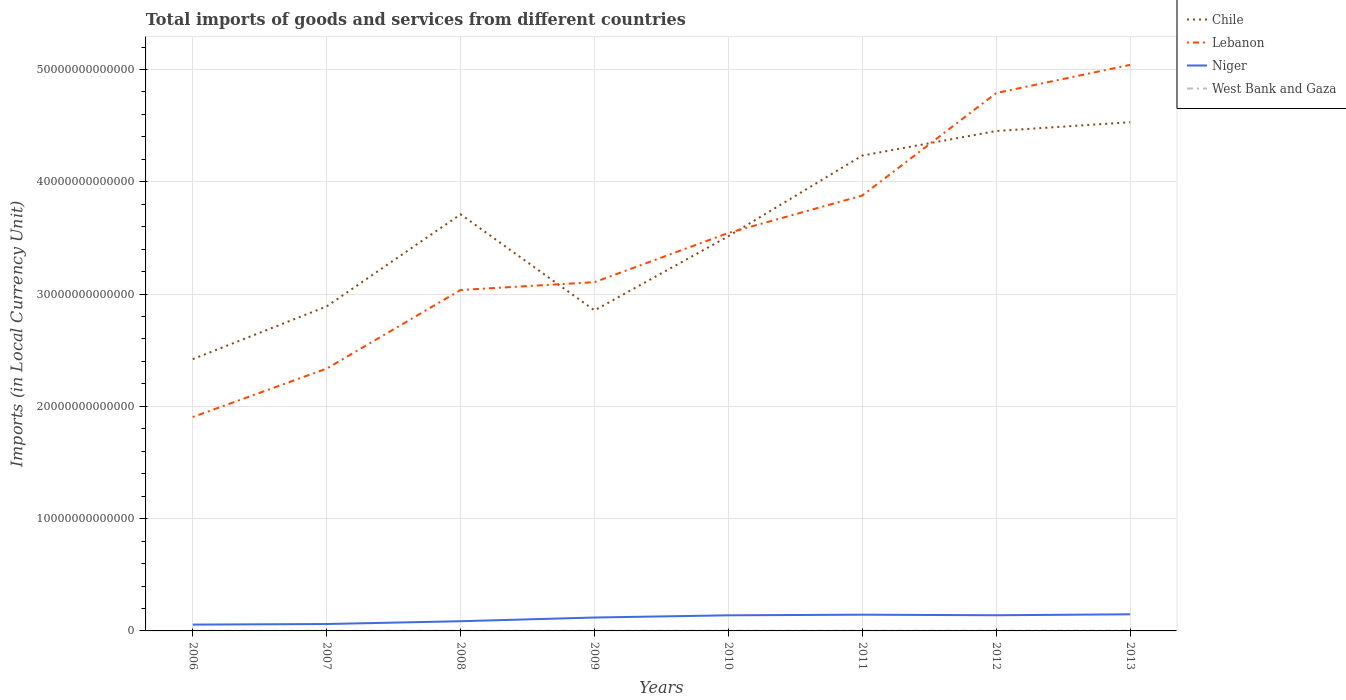How many different coloured lines are there?
Your answer should be very brief. 4. Across all years, what is the maximum Amount of goods and services imports in Lebanon?
Keep it short and to the point. 1.90e+13. What is the total Amount of goods and services imports in Niger in the graph?
Your response must be concise. -2.48e+11. What is the difference between the highest and the second highest Amount of goods and services imports in Niger?
Give a very brief answer. 9.18e+11. Is the Amount of goods and services imports in Chile strictly greater than the Amount of goods and services imports in Niger over the years?
Ensure brevity in your answer.  No. How many lines are there?
Your answer should be compact. 4. What is the difference between two consecutive major ticks on the Y-axis?
Your response must be concise. 1.00e+13. Does the graph contain grids?
Provide a short and direct response. Yes. Where does the legend appear in the graph?
Offer a very short reply. Top right. How many legend labels are there?
Your answer should be very brief. 4. What is the title of the graph?
Provide a succinct answer. Total imports of goods and services from different countries. What is the label or title of the X-axis?
Give a very brief answer. Years. What is the label or title of the Y-axis?
Your answer should be very brief. Imports (in Local Currency Unit). What is the Imports (in Local Currency Unit) in Chile in 2006?
Your answer should be compact. 2.42e+13. What is the Imports (in Local Currency Unit) in Lebanon in 2006?
Give a very brief answer. 1.90e+13. What is the Imports (in Local Currency Unit) in Niger in 2006?
Provide a short and direct response. 5.63e+11. What is the Imports (in Local Currency Unit) in West Bank and Gaza in 2006?
Give a very brief answer. 1.64e+1. What is the Imports (in Local Currency Unit) of Chile in 2007?
Your answer should be compact. 2.89e+13. What is the Imports (in Local Currency Unit) of Lebanon in 2007?
Keep it short and to the point. 2.34e+13. What is the Imports (in Local Currency Unit) in Niger in 2007?
Give a very brief answer. 6.15e+11. What is the Imports (in Local Currency Unit) in West Bank and Gaza in 2007?
Offer a very short reply. 1.76e+1. What is the Imports (in Local Currency Unit) of Chile in 2008?
Provide a short and direct response. 3.71e+13. What is the Imports (in Local Currency Unit) of Lebanon in 2008?
Provide a short and direct response. 3.04e+13. What is the Imports (in Local Currency Unit) of Niger in 2008?
Ensure brevity in your answer.  8.64e+11. What is the Imports (in Local Currency Unit) of West Bank and Gaza in 2008?
Ensure brevity in your answer.  1.64e+1. What is the Imports (in Local Currency Unit) in Chile in 2009?
Your answer should be compact. 2.85e+13. What is the Imports (in Local Currency Unit) in Lebanon in 2009?
Make the answer very short. 3.11e+13. What is the Imports (in Local Currency Unit) of Niger in 2009?
Offer a terse response. 1.19e+12. What is the Imports (in Local Currency Unit) of West Bank and Gaza in 2009?
Provide a short and direct response. 1.95e+1. What is the Imports (in Local Currency Unit) of Chile in 2010?
Your answer should be compact. 3.52e+13. What is the Imports (in Local Currency Unit) of Lebanon in 2010?
Keep it short and to the point. 3.54e+13. What is the Imports (in Local Currency Unit) of Niger in 2010?
Your response must be concise. 1.39e+12. What is the Imports (in Local Currency Unit) of West Bank and Gaza in 2010?
Your answer should be very brief. 1.96e+1. What is the Imports (in Local Currency Unit) in Chile in 2011?
Offer a very short reply. 4.23e+13. What is the Imports (in Local Currency Unit) in Lebanon in 2011?
Make the answer very short. 3.88e+13. What is the Imports (in Local Currency Unit) in Niger in 2011?
Keep it short and to the point. 1.45e+12. What is the Imports (in Local Currency Unit) of West Bank and Gaza in 2011?
Your response must be concise. 2.05e+1. What is the Imports (in Local Currency Unit) in Chile in 2012?
Offer a terse response. 4.45e+13. What is the Imports (in Local Currency Unit) in Lebanon in 2012?
Give a very brief answer. 4.79e+13. What is the Imports (in Local Currency Unit) in Niger in 2012?
Your response must be concise. 1.40e+12. What is the Imports (in Local Currency Unit) of West Bank and Gaza in 2012?
Ensure brevity in your answer.  2.43e+1. What is the Imports (in Local Currency Unit) in Chile in 2013?
Provide a succinct answer. 4.53e+13. What is the Imports (in Local Currency Unit) of Lebanon in 2013?
Provide a succinct answer. 5.04e+13. What is the Imports (in Local Currency Unit) of Niger in 2013?
Offer a very short reply. 1.48e+12. What is the Imports (in Local Currency Unit) in West Bank and Gaza in 2013?
Your response must be concise. 2.46e+1. Across all years, what is the maximum Imports (in Local Currency Unit) of Chile?
Give a very brief answer. 4.53e+13. Across all years, what is the maximum Imports (in Local Currency Unit) in Lebanon?
Make the answer very short. 5.04e+13. Across all years, what is the maximum Imports (in Local Currency Unit) of Niger?
Give a very brief answer. 1.48e+12. Across all years, what is the maximum Imports (in Local Currency Unit) in West Bank and Gaza?
Offer a terse response. 2.46e+1. Across all years, what is the minimum Imports (in Local Currency Unit) of Chile?
Offer a very short reply. 2.42e+13. Across all years, what is the minimum Imports (in Local Currency Unit) in Lebanon?
Ensure brevity in your answer.  1.90e+13. Across all years, what is the minimum Imports (in Local Currency Unit) of Niger?
Your answer should be very brief. 5.63e+11. Across all years, what is the minimum Imports (in Local Currency Unit) of West Bank and Gaza?
Make the answer very short. 1.64e+1. What is the total Imports (in Local Currency Unit) of Chile in the graph?
Your answer should be compact. 2.86e+14. What is the total Imports (in Local Currency Unit) in Lebanon in the graph?
Give a very brief answer. 2.76e+14. What is the total Imports (in Local Currency Unit) of Niger in the graph?
Make the answer very short. 8.95e+12. What is the total Imports (in Local Currency Unit) of West Bank and Gaza in the graph?
Offer a very short reply. 1.59e+11. What is the difference between the Imports (in Local Currency Unit) in Chile in 2006 and that in 2007?
Your response must be concise. -4.70e+12. What is the difference between the Imports (in Local Currency Unit) in Lebanon in 2006 and that in 2007?
Keep it short and to the point. -4.32e+12. What is the difference between the Imports (in Local Currency Unit) of Niger in 2006 and that in 2007?
Provide a short and direct response. -5.28e+1. What is the difference between the Imports (in Local Currency Unit) in West Bank and Gaza in 2006 and that in 2007?
Make the answer very short. -1.18e+09. What is the difference between the Imports (in Local Currency Unit) in Chile in 2006 and that in 2008?
Make the answer very short. -1.29e+13. What is the difference between the Imports (in Local Currency Unit) of Lebanon in 2006 and that in 2008?
Keep it short and to the point. -1.13e+13. What is the difference between the Imports (in Local Currency Unit) of Niger in 2006 and that in 2008?
Ensure brevity in your answer.  -3.01e+11. What is the difference between the Imports (in Local Currency Unit) in West Bank and Gaza in 2006 and that in 2008?
Offer a terse response. -1.64e+07. What is the difference between the Imports (in Local Currency Unit) of Chile in 2006 and that in 2009?
Keep it short and to the point. -4.34e+12. What is the difference between the Imports (in Local Currency Unit) of Lebanon in 2006 and that in 2009?
Your response must be concise. -1.20e+13. What is the difference between the Imports (in Local Currency Unit) in Niger in 2006 and that in 2009?
Your answer should be very brief. -6.31e+11. What is the difference between the Imports (in Local Currency Unit) in West Bank and Gaza in 2006 and that in 2009?
Your answer should be compact. -3.05e+09. What is the difference between the Imports (in Local Currency Unit) in Chile in 2006 and that in 2010?
Keep it short and to the point. -1.09e+13. What is the difference between the Imports (in Local Currency Unit) of Lebanon in 2006 and that in 2010?
Keep it short and to the point. -1.64e+13. What is the difference between the Imports (in Local Currency Unit) of Niger in 2006 and that in 2010?
Provide a short and direct response. -8.28e+11. What is the difference between the Imports (in Local Currency Unit) of West Bank and Gaza in 2006 and that in 2010?
Keep it short and to the point. -3.21e+09. What is the difference between the Imports (in Local Currency Unit) of Chile in 2006 and that in 2011?
Provide a succinct answer. -1.81e+13. What is the difference between the Imports (in Local Currency Unit) of Lebanon in 2006 and that in 2011?
Your answer should be very brief. -1.97e+13. What is the difference between the Imports (in Local Currency Unit) of Niger in 2006 and that in 2011?
Offer a very short reply. -8.83e+11. What is the difference between the Imports (in Local Currency Unit) in West Bank and Gaza in 2006 and that in 2011?
Provide a short and direct response. -4.06e+09. What is the difference between the Imports (in Local Currency Unit) of Chile in 2006 and that in 2012?
Your response must be concise. -2.03e+13. What is the difference between the Imports (in Local Currency Unit) of Lebanon in 2006 and that in 2012?
Your answer should be very brief. -2.89e+13. What is the difference between the Imports (in Local Currency Unit) of Niger in 2006 and that in 2012?
Give a very brief answer. -8.32e+11. What is the difference between the Imports (in Local Currency Unit) of West Bank and Gaza in 2006 and that in 2012?
Ensure brevity in your answer.  -7.83e+09. What is the difference between the Imports (in Local Currency Unit) of Chile in 2006 and that in 2013?
Keep it short and to the point. -2.11e+13. What is the difference between the Imports (in Local Currency Unit) in Lebanon in 2006 and that in 2013?
Ensure brevity in your answer.  -3.14e+13. What is the difference between the Imports (in Local Currency Unit) in Niger in 2006 and that in 2013?
Make the answer very short. -9.18e+11. What is the difference between the Imports (in Local Currency Unit) in West Bank and Gaza in 2006 and that in 2013?
Your response must be concise. -8.13e+09. What is the difference between the Imports (in Local Currency Unit) in Chile in 2007 and that in 2008?
Give a very brief answer. -8.20e+12. What is the difference between the Imports (in Local Currency Unit) in Lebanon in 2007 and that in 2008?
Give a very brief answer. -7.00e+12. What is the difference between the Imports (in Local Currency Unit) of Niger in 2007 and that in 2008?
Your answer should be compact. -2.48e+11. What is the difference between the Imports (in Local Currency Unit) in West Bank and Gaza in 2007 and that in 2008?
Your response must be concise. 1.16e+09. What is the difference between the Imports (in Local Currency Unit) in Chile in 2007 and that in 2009?
Offer a terse response. 3.57e+11. What is the difference between the Imports (in Local Currency Unit) in Lebanon in 2007 and that in 2009?
Your answer should be very brief. -7.70e+12. What is the difference between the Imports (in Local Currency Unit) of Niger in 2007 and that in 2009?
Your answer should be compact. -5.79e+11. What is the difference between the Imports (in Local Currency Unit) in West Bank and Gaza in 2007 and that in 2009?
Make the answer very short. -1.87e+09. What is the difference between the Imports (in Local Currency Unit) of Chile in 2007 and that in 2010?
Give a very brief answer. -6.25e+12. What is the difference between the Imports (in Local Currency Unit) of Lebanon in 2007 and that in 2010?
Your answer should be very brief. -1.21e+13. What is the difference between the Imports (in Local Currency Unit) of Niger in 2007 and that in 2010?
Make the answer very short. -7.75e+11. What is the difference between the Imports (in Local Currency Unit) of West Bank and Gaza in 2007 and that in 2010?
Keep it short and to the point. -2.03e+09. What is the difference between the Imports (in Local Currency Unit) in Chile in 2007 and that in 2011?
Offer a terse response. -1.34e+13. What is the difference between the Imports (in Local Currency Unit) in Lebanon in 2007 and that in 2011?
Provide a short and direct response. -1.54e+13. What is the difference between the Imports (in Local Currency Unit) in Niger in 2007 and that in 2011?
Give a very brief answer. -8.30e+11. What is the difference between the Imports (in Local Currency Unit) of West Bank and Gaza in 2007 and that in 2011?
Keep it short and to the point. -2.88e+09. What is the difference between the Imports (in Local Currency Unit) in Chile in 2007 and that in 2012?
Provide a short and direct response. -1.56e+13. What is the difference between the Imports (in Local Currency Unit) of Lebanon in 2007 and that in 2012?
Provide a short and direct response. -2.45e+13. What is the difference between the Imports (in Local Currency Unit) of Niger in 2007 and that in 2012?
Give a very brief answer. -7.80e+11. What is the difference between the Imports (in Local Currency Unit) of West Bank and Gaza in 2007 and that in 2012?
Offer a very short reply. -6.65e+09. What is the difference between the Imports (in Local Currency Unit) in Chile in 2007 and that in 2013?
Keep it short and to the point. -1.64e+13. What is the difference between the Imports (in Local Currency Unit) in Lebanon in 2007 and that in 2013?
Provide a succinct answer. -2.70e+13. What is the difference between the Imports (in Local Currency Unit) of Niger in 2007 and that in 2013?
Keep it short and to the point. -8.65e+11. What is the difference between the Imports (in Local Currency Unit) of West Bank and Gaza in 2007 and that in 2013?
Offer a terse response. -6.95e+09. What is the difference between the Imports (in Local Currency Unit) in Chile in 2008 and that in 2009?
Make the answer very short. 8.56e+12. What is the difference between the Imports (in Local Currency Unit) of Lebanon in 2008 and that in 2009?
Your response must be concise. -6.97e+11. What is the difference between the Imports (in Local Currency Unit) in Niger in 2008 and that in 2009?
Your response must be concise. -3.31e+11. What is the difference between the Imports (in Local Currency Unit) of West Bank and Gaza in 2008 and that in 2009?
Provide a short and direct response. -3.03e+09. What is the difference between the Imports (in Local Currency Unit) of Chile in 2008 and that in 2010?
Give a very brief answer. 1.95e+12. What is the difference between the Imports (in Local Currency Unit) in Lebanon in 2008 and that in 2010?
Offer a terse response. -5.08e+12. What is the difference between the Imports (in Local Currency Unit) of Niger in 2008 and that in 2010?
Your answer should be compact. -5.27e+11. What is the difference between the Imports (in Local Currency Unit) in West Bank and Gaza in 2008 and that in 2010?
Your response must be concise. -3.19e+09. What is the difference between the Imports (in Local Currency Unit) in Chile in 2008 and that in 2011?
Offer a very short reply. -5.23e+12. What is the difference between the Imports (in Local Currency Unit) of Lebanon in 2008 and that in 2011?
Your response must be concise. -8.41e+12. What is the difference between the Imports (in Local Currency Unit) in Niger in 2008 and that in 2011?
Provide a short and direct response. -5.82e+11. What is the difference between the Imports (in Local Currency Unit) in West Bank and Gaza in 2008 and that in 2011?
Offer a very short reply. -4.04e+09. What is the difference between the Imports (in Local Currency Unit) of Chile in 2008 and that in 2012?
Provide a succinct answer. -7.42e+12. What is the difference between the Imports (in Local Currency Unit) in Lebanon in 2008 and that in 2012?
Ensure brevity in your answer.  -1.75e+13. What is the difference between the Imports (in Local Currency Unit) of Niger in 2008 and that in 2012?
Provide a succinct answer. -5.32e+11. What is the difference between the Imports (in Local Currency Unit) in West Bank and Gaza in 2008 and that in 2012?
Your answer should be very brief. -7.81e+09. What is the difference between the Imports (in Local Currency Unit) of Chile in 2008 and that in 2013?
Provide a succinct answer. -8.20e+12. What is the difference between the Imports (in Local Currency Unit) in Lebanon in 2008 and that in 2013?
Give a very brief answer. -2.00e+13. What is the difference between the Imports (in Local Currency Unit) in Niger in 2008 and that in 2013?
Provide a succinct answer. -6.17e+11. What is the difference between the Imports (in Local Currency Unit) of West Bank and Gaza in 2008 and that in 2013?
Your response must be concise. -8.12e+09. What is the difference between the Imports (in Local Currency Unit) in Chile in 2009 and that in 2010?
Your response must be concise. -6.61e+12. What is the difference between the Imports (in Local Currency Unit) in Lebanon in 2009 and that in 2010?
Offer a terse response. -4.38e+12. What is the difference between the Imports (in Local Currency Unit) in Niger in 2009 and that in 2010?
Offer a very short reply. -1.96e+11. What is the difference between the Imports (in Local Currency Unit) of West Bank and Gaza in 2009 and that in 2010?
Ensure brevity in your answer.  -1.60e+08. What is the difference between the Imports (in Local Currency Unit) in Chile in 2009 and that in 2011?
Provide a short and direct response. -1.38e+13. What is the difference between the Imports (in Local Currency Unit) in Lebanon in 2009 and that in 2011?
Offer a terse response. -7.72e+12. What is the difference between the Imports (in Local Currency Unit) of Niger in 2009 and that in 2011?
Make the answer very short. -2.51e+11. What is the difference between the Imports (in Local Currency Unit) of West Bank and Gaza in 2009 and that in 2011?
Your answer should be very brief. -1.01e+09. What is the difference between the Imports (in Local Currency Unit) of Chile in 2009 and that in 2012?
Make the answer very short. -1.60e+13. What is the difference between the Imports (in Local Currency Unit) in Lebanon in 2009 and that in 2012?
Offer a very short reply. -1.68e+13. What is the difference between the Imports (in Local Currency Unit) in Niger in 2009 and that in 2012?
Keep it short and to the point. -2.01e+11. What is the difference between the Imports (in Local Currency Unit) of West Bank and Gaza in 2009 and that in 2012?
Your response must be concise. -4.78e+09. What is the difference between the Imports (in Local Currency Unit) of Chile in 2009 and that in 2013?
Provide a succinct answer. -1.68e+13. What is the difference between the Imports (in Local Currency Unit) in Lebanon in 2009 and that in 2013?
Your answer should be compact. -1.94e+13. What is the difference between the Imports (in Local Currency Unit) of Niger in 2009 and that in 2013?
Your answer should be compact. -2.86e+11. What is the difference between the Imports (in Local Currency Unit) of West Bank and Gaza in 2009 and that in 2013?
Provide a short and direct response. -5.09e+09. What is the difference between the Imports (in Local Currency Unit) of Chile in 2010 and that in 2011?
Give a very brief answer. -7.18e+12. What is the difference between the Imports (in Local Currency Unit) in Lebanon in 2010 and that in 2011?
Offer a very short reply. -3.33e+12. What is the difference between the Imports (in Local Currency Unit) of Niger in 2010 and that in 2011?
Make the answer very short. -5.48e+1. What is the difference between the Imports (in Local Currency Unit) in West Bank and Gaza in 2010 and that in 2011?
Give a very brief answer. -8.53e+08. What is the difference between the Imports (in Local Currency Unit) in Chile in 2010 and that in 2012?
Ensure brevity in your answer.  -9.37e+12. What is the difference between the Imports (in Local Currency Unit) in Lebanon in 2010 and that in 2012?
Keep it short and to the point. -1.25e+13. What is the difference between the Imports (in Local Currency Unit) in Niger in 2010 and that in 2012?
Your answer should be compact. -4.62e+09. What is the difference between the Imports (in Local Currency Unit) of West Bank and Gaza in 2010 and that in 2012?
Keep it short and to the point. -4.62e+09. What is the difference between the Imports (in Local Currency Unit) of Chile in 2010 and that in 2013?
Give a very brief answer. -1.02e+13. What is the difference between the Imports (in Local Currency Unit) in Lebanon in 2010 and that in 2013?
Your answer should be very brief. -1.50e+13. What is the difference between the Imports (in Local Currency Unit) of Niger in 2010 and that in 2013?
Provide a short and direct response. -9.01e+1. What is the difference between the Imports (in Local Currency Unit) in West Bank and Gaza in 2010 and that in 2013?
Keep it short and to the point. -4.93e+09. What is the difference between the Imports (in Local Currency Unit) of Chile in 2011 and that in 2012?
Your answer should be compact. -2.19e+12. What is the difference between the Imports (in Local Currency Unit) of Lebanon in 2011 and that in 2012?
Offer a terse response. -9.13e+12. What is the difference between the Imports (in Local Currency Unit) of Niger in 2011 and that in 2012?
Ensure brevity in your answer.  5.02e+1. What is the difference between the Imports (in Local Currency Unit) of West Bank and Gaza in 2011 and that in 2012?
Your answer should be very brief. -3.77e+09. What is the difference between the Imports (in Local Currency Unit) of Chile in 2011 and that in 2013?
Give a very brief answer. -2.97e+12. What is the difference between the Imports (in Local Currency Unit) in Lebanon in 2011 and that in 2013?
Make the answer very short. -1.16e+13. What is the difference between the Imports (in Local Currency Unit) of Niger in 2011 and that in 2013?
Give a very brief answer. -3.53e+1. What is the difference between the Imports (in Local Currency Unit) in West Bank and Gaza in 2011 and that in 2013?
Offer a terse response. -4.07e+09. What is the difference between the Imports (in Local Currency Unit) of Chile in 2012 and that in 2013?
Your answer should be very brief. -7.85e+11. What is the difference between the Imports (in Local Currency Unit) of Lebanon in 2012 and that in 2013?
Give a very brief answer. -2.51e+12. What is the difference between the Imports (in Local Currency Unit) in Niger in 2012 and that in 2013?
Make the answer very short. -8.54e+1. What is the difference between the Imports (in Local Currency Unit) of West Bank and Gaza in 2012 and that in 2013?
Offer a very short reply. -3.08e+08. What is the difference between the Imports (in Local Currency Unit) of Chile in 2006 and the Imports (in Local Currency Unit) of Lebanon in 2007?
Give a very brief answer. 8.40e+11. What is the difference between the Imports (in Local Currency Unit) in Chile in 2006 and the Imports (in Local Currency Unit) in Niger in 2007?
Provide a short and direct response. 2.36e+13. What is the difference between the Imports (in Local Currency Unit) of Chile in 2006 and the Imports (in Local Currency Unit) of West Bank and Gaza in 2007?
Your response must be concise. 2.42e+13. What is the difference between the Imports (in Local Currency Unit) of Lebanon in 2006 and the Imports (in Local Currency Unit) of Niger in 2007?
Ensure brevity in your answer.  1.84e+13. What is the difference between the Imports (in Local Currency Unit) in Lebanon in 2006 and the Imports (in Local Currency Unit) in West Bank and Gaza in 2007?
Offer a very short reply. 1.90e+13. What is the difference between the Imports (in Local Currency Unit) of Niger in 2006 and the Imports (in Local Currency Unit) of West Bank and Gaza in 2007?
Make the answer very short. 5.45e+11. What is the difference between the Imports (in Local Currency Unit) of Chile in 2006 and the Imports (in Local Currency Unit) of Lebanon in 2008?
Give a very brief answer. -6.16e+12. What is the difference between the Imports (in Local Currency Unit) in Chile in 2006 and the Imports (in Local Currency Unit) in Niger in 2008?
Make the answer very short. 2.33e+13. What is the difference between the Imports (in Local Currency Unit) of Chile in 2006 and the Imports (in Local Currency Unit) of West Bank and Gaza in 2008?
Give a very brief answer. 2.42e+13. What is the difference between the Imports (in Local Currency Unit) of Lebanon in 2006 and the Imports (in Local Currency Unit) of Niger in 2008?
Make the answer very short. 1.82e+13. What is the difference between the Imports (in Local Currency Unit) of Lebanon in 2006 and the Imports (in Local Currency Unit) of West Bank and Gaza in 2008?
Ensure brevity in your answer.  1.90e+13. What is the difference between the Imports (in Local Currency Unit) of Niger in 2006 and the Imports (in Local Currency Unit) of West Bank and Gaza in 2008?
Provide a succinct answer. 5.46e+11. What is the difference between the Imports (in Local Currency Unit) in Chile in 2006 and the Imports (in Local Currency Unit) in Lebanon in 2009?
Make the answer very short. -6.86e+12. What is the difference between the Imports (in Local Currency Unit) in Chile in 2006 and the Imports (in Local Currency Unit) in Niger in 2009?
Keep it short and to the point. 2.30e+13. What is the difference between the Imports (in Local Currency Unit) of Chile in 2006 and the Imports (in Local Currency Unit) of West Bank and Gaza in 2009?
Offer a terse response. 2.42e+13. What is the difference between the Imports (in Local Currency Unit) of Lebanon in 2006 and the Imports (in Local Currency Unit) of Niger in 2009?
Offer a very short reply. 1.79e+13. What is the difference between the Imports (in Local Currency Unit) in Lebanon in 2006 and the Imports (in Local Currency Unit) in West Bank and Gaza in 2009?
Offer a very short reply. 1.90e+13. What is the difference between the Imports (in Local Currency Unit) of Niger in 2006 and the Imports (in Local Currency Unit) of West Bank and Gaza in 2009?
Give a very brief answer. 5.43e+11. What is the difference between the Imports (in Local Currency Unit) in Chile in 2006 and the Imports (in Local Currency Unit) in Lebanon in 2010?
Your answer should be very brief. -1.12e+13. What is the difference between the Imports (in Local Currency Unit) in Chile in 2006 and the Imports (in Local Currency Unit) in Niger in 2010?
Provide a short and direct response. 2.28e+13. What is the difference between the Imports (in Local Currency Unit) in Chile in 2006 and the Imports (in Local Currency Unit) in West Bank and Gaza in 2010?
Your answer should be compact. 2.42e+13. What is the difference between the Imports (in Local Currency Unit) of Lebanon in 2006 and the Imports (in Local Currency Unit) of Niger in 2010?
Your response must be concise. 1.77e+13. What is the difference between the Imports (in Local Currency Unit) in Lebanon in 2006 and the Imports (in Local Currency Unit) in West Bank and Gaza in 2010?
Provide a succinct answer. 1.90e+13. What is the difference between the Imports (in Local Currency Unit) of Niger in 2006 and the Imports (in Local Currency Unit) of West Bank and Gaza in 2010?
Your answer should be very brief. 5.43e+11. What is the difference between the Imports (in Local Currency Unit) of Chile in 2006 and the Imports (in Local Currency Unit) of Lebanon in 2011?
Offer a very short reply. -1.46e+13. What is the difference between the Imports (in Local Currency Unit) in Chile in 2006 and the Imports (in Local Currency Unit) in Niger in 2011?
Give a very brief answer. 2.28e+13. What is the difference between the Imports (in Local Currency Unit) of Chile in 2006 and the Imports (in Local Currency Unit) of West Bank and Gaza in 2011?
Offer a very short reply. 2.42e+13. What is the difference between the Imports (in Local Currency Unit) in Lebanon in 2006 and the Imports (in Local Currency Unit) in Niger in 2011?
Your answer should be compact. 1.76e+13. What is the difference between the Imports (in Local Currency Unit) of Lebanon in 2006 and the Imports (in Local Currency Unit) of West Bank and Gaza in 2011?
Make the answer very short. 1.90e+13. What is the difference between the Imports (in Local Currency Unit) in Niger in 2006 and the Imports (in Local Currency Unit) in West Bank and Gaza in 2011?
Provide a short and direct response. 5.42e+11. What is the difference between the Imports (in Local Currency Unit) in Chile in 2006 and the Imports (in Local Currency Unit) in Lebanon in 2012?
Provide a succinct answer. -2.37e+13. What is the difference between the Imports (in Local Currency Unit) in Chile in 2006 and the Imports (in Local Currency Unit) in Niger in 2012?
Ensure brevity in your answer.  2.28e+13. What is the difference between the Imports (in Local Currency Unit) of Chile in 2006 and the Imports (in Local Currency Unit) of West Bank and Gaza in 2012?
Offer a terse response. 2.42e+13. What is the difference between the Imports (in Local Currency Unit) of Lebanon in 2006 and the Imports (in Local Currency Unit) of Niger in 2012?
Make the answer very short. 1.77e+13. What is the difference between the Imports (in Local Currency Unit) of Lebanon in 2006 and the Imports (in Local Currency Unit) of West Bank and Gaza in 2012?
Give a very brief answer. 1.90e+13. What is the difference between the Imports (in Local Currency Unit) of Niger in 2006 and the Imports (in Local Currency Unit) of West Bank and Gaza in 2012?
Your answer should be very brief. 5.38e+11. What is the difference between the Imports (in Local Currency Unit) in Chile in 2006 and the Imports (in Local Currency Unit) in Lebanon in 2013?
Your answer should be compact. -2.62e+13. What is the difference between the Imports (in Local Currency Unit) of Chile in 2006 and the Imports (in Local Currency Unit) of Niger in 2013?
Your answer should be very brief. 2.27e+13. What is the difference between the Imports (in Local Currency Unit) in Chile in 2006 and the Imports (in Local Currency Unit) in West Bank and Gaza in 2013?
Give a very brief answer. 2.42e+13. What is the difference between the Imports (in Local Currency Unit) in Lebanon in 2006 and the Imports (in Local Currency Unit) in Niger in 2013?
Your answer should be very brief. 1.76e+13. What is the difference between the Imports (in Local Currency Unit) of Lebanon in 2006 and the Imports (in Local Currency Unit) of West Bank and Gaza in 2013?
Offer a terse response. 1.90e+13. What is the difference between the Imports (in Local Currency Unit) in Niger in 2006 and the Imports (in Local Currency Unit) in West Bank and Gaza in 2013?
Ensure brevity in your answer.  5.38e+11. What is the difference between the Imports (in Local Currency Unit) of Chile in 2007 and the Imports (in Local Currency Unit) of Lebanon in 2008?
Offer a very short reply. -1.46e+12. What is the difference between the Imports (in Local Currency Unit) in Chile in 2007 and the Imports (in Local Currency Unit) in Niger in 2008?
Offer a terse response. 2.80e+13. What is the difference between the Imports (in Local Currency Unit) in Chile in 2007 and the Imports (in Local Currency Unit) in West Bank and Gaza in 2008?
Your answer should be very brief. 2.89e+13. What is the difference between the Imports (in Local Currency Unit) of Lebanon in 2007 and the Imports (in Local Currency Unit) of Niger in 2008?
Provide a succinct answer. 2.25e+13. What is the difference between the Imports (in Local Currency Unit) of Lebanon in 2007 and the Imports (in Local Currency Unit) of West Bank and Gaza in 2008?
Keep it short and to the point. 2.33e+13. What is the difference between the Imports (in Local Currency Unit) in Niger in 2007 and the Imports (in Local Currency Unit) in West Bank and Gaza in 2008?
Keep it short and to the point. 5.99e+11. What is the difference between the Imports (in Local Currency Unit) of Chile in 2007 and the Imports (in Local Currency Unit) of Lebanon in 2009?
Offer a very short reply. -2.16e+12. What is the difference between the Imports (in Local Currency Unit) in Chile in 2007 and the Imports (in Local Currency Unit) in Niger in 2009?
Offer a terse response. 2.77e+13. What is the difference between the Imports (in Local Currency Unit) in Chile in 2007 and the Imports (in Local Currency Unit) in West Bank and Gaza in 2009?
Your answer should be very brief. 2.89e+13. What is the difference between the Imports (in Local Currency Unit) of Lebanon in 2007 and the Imports (in Local Currency Unit) of Niger in 2009?
Provide a short and direct response. 2.22e+13. What is the difference between the Imports (in Local Currency Unit) in Lebanon in 2007 and the Imports (in Local Currency Unit) in West Bank and Gaza in 2009?
Keep it short and to the point. 2.33e+13. What is the difference between the Imports (in Local Currency Unit) of Niger in 2007 and the Imports (in Local Currency Unit) of West Bank and Gaza in 2009?
Your answer should be compact. 5.96e+11. What is the difference between the Imports (in Local Currency Unit) of Chile in 2007 and the Imports (in Local Currency Unit) of Lebanon in 2010?
Offer a very short reply. -6.54e+12. What is the difference between the Imports (in Local Currency Unit) of Chile in 2007 and the Imports (in Local Currency Unit) of Niger in 2010?
Your response must be concise. 2.75e+13. What is the difference between the Imports (in Local Currency Unit) in Chile in 2007 and the Imports (in Local Currency Unit) in West Bank and Gaza in 2010?
Keep it short and to the point. 2.89e+13. What is the difference between the Imports (in Local Currency Unit) of Lebanon in 2007 and the Imports (in Local Currency Unit) of Niger in 2010?
Keep it short and to the point. 2.20e+13. What is the difference between the Imports (in Local Currency Unit) of Lebanon in 2007 and the Imports (in Local Currency Unit) of West Bank and Gaza in 2010?
Give a very brief answer. 2.33e+13. What is the difference between the Imports (in Local Currency Unit) in Niger in 2007 and the Imports (in Local Currency Unit) in West Bank and Gaza in 2010?
Ensure brevity in your answer.  5.96e+11. What is the difference between the Imports (in Local Currency Unit) of Chile in 2007 and the Imports (in Local Currency Unit) of Lebanon in 2011?
Ensure brevity in your answer.  -9.87e+12. What is the difference between the Imports (in Local Currency Unit) in Chile in 2007 and the Imports (in Local Currency Unit) in Niger in 2011?
Make the answer very short. 2.75e+13. What is the difference between the Imports (in Local Currency Unit) in Chile in 2007 and the Imports (in Local Currency Unit) in West Bank and Gaza in 2011?
Ensure brevity in your answer.  2.89e+13. What is the difference between the Imports (in Local Currency Unit) of Lebanon in 2007 and the Imports (in Local Currency Unit) of Niger in 2011?
Ensure brevity in your answer.  2.19e+13. What is the difference between the Imports (in Local Currency Unit) of Lebanon in 2007 and the Imports (in Local Currency Unit) of West Bank and Gaza in 2011?
Make the answer very short. 2.33e+13. What is the difference between the Imports (in Local Currency Unit) in Niger in 2007 and the Imports (in Local Currency Unit) in West Bank and Gaza in 2011?
Keep it short and to the point. 5.95e+11. What is the difference between the Imports (in Local Currency Unit) of Chile in 2007 and the Imports (in Local Currency Unit) of Lebanon in 2012?
Your answer should be very brief. -1.90e+13. What is the difference between the Imports (in Local Currency Unit) of Chile in 2007 and the Imports (in Local Currency Unit) of Niger in 2012?
Your answer should be very brief. 2.75e+13. What is the difference between the Imports (in Local Currency Unit) in Chile in 2007 and the Imports (in Local Currency Unit) in West Bank and Gaza in 2012?
Offer a very short reply. 2.89e+13. What is the difference between the Imports (in Local Currency Unit) in Lebanon in 2007 and the Imports (in Local Currency Unit) in Niger in 2012?
Your response must be concise. 2.20e+13. What is the difference between the Imports (in Local Currency Unit) of Lebanon in 2007 and the Imports (in Local Currency Unit) of West Bank and Gaza in 2012?
Provide a short and direct response. 2.33e+13. What is the difference between the Imports (in Local Currency Unit) in Niger in 2007 and the Imports (in Local Currency Unit) in West Bank and Gaza in 2012?
Your response must be concise. 5.91e+11. What is the difference between the Imports (in Local Currency Unit) in Chile in 2007 and the Imports (in Local Currency Unit) in Lebanon in 2013?
Your answer should be very brief. -2.15e+13. What is the difference between the Imports (in Local Currency Unit) in Chile in 2007 and the Imports (in Local Currency Unit) in Niger in 2013?
Offer a terse response. 2.74e+13. What is the difference between the Imports (in Local Currency Unit) in Chile in 2007 and the Imports (in Local Currency Unit) in West Bank and Gaza in 2013?
Offer a very short reply. 2.89e+13. What is the difference between the Imports (in Local Currency Unit) in Lebanon in 2007 and the Imports (in Local Currency Unit) in Niger in 2013?
Keep it short and to the point. 2.19e+13. What is the difference between the Imports (in Local Currency Unit) in Lebanon in 2007 and the Imports (in Local Currency Unit) in West Bank and Gaza in 2013?
Keep it short and to the point. 2.33e+13. What is the difference between the Imports (in Local Currency Unit) in Niger in 2007 and the Imports (in Local Currency Unit) in West Bank and Gaza in 2013?
Keep it short and to the point. 5.91e+11. What is the difference between the Imports (in Local Currency Unit) in Chile in 2008 and the Imports (in Local Currency Unit) in Lebanon in 2009?
Provide a succinct answer. 6.04e+12. What is the difference between the Imports (in Local Currency Unit) of Chile in 2008 and the Imports (in Local Currency Unit) of Niger in 2009?
Your answer should be very brief. 3.59e+13. What is the difference between the Imports (in Local Currency Unit) in Chile in 2008 and the Imports (in Local Currency Unit) in West Bank and Gaza in 2009?
Offer a very short reply. 3.71e+13. What is the difference between the Imports (in Local Currency Unit) in Lebanon in 2008 and the Imports (in Local Currency Unit) in Niger in 2009?
Your response must be concise. 2.92e+13. What is the difference between the Imports (in Local Currency Unit) of Lebanon in 2008 and the Imports (in Local Currency Unit) of West Bank and Gaza in 2009?
Keep it short and to the point. 3.03e+13. What is the difference between the Imports (in Local Currency Unit) in Niger in 2008 and the Imports (in Local Currency Unit) in West Bank and Gaza in 2009?
Keep it short and to the point. 8.44e+11. What is the difference between the Imports (in Local Currency Unit) in Chile in 2008 and the Imports (in Local Currency Unit) in Lebanon in 2010?
Give a very brief answer. 1.66e+12. What is the difference between the Imports (in Local Currency Unit) of Chile in 2008 and the Imports (in Local Currency Unit) of Niger in 2010?
Make the answer very short. 3.57e+13. What is the difference between the Imports (in Local Currency Unit) in Chile in 2008 and the Imports (in Local Currency Unit) in West Bank and Gaza in 2010?
Your response must be concise. 3.71e+13. What is the difference between the Imports (in Local Currency Unit) of Lebanon in 2008 and the Imports (in Local Currency Unit) of Niger in 2010?
Your response must be concise. 2.90e+13. What is the difference between the Imports (in Local Currency Unit) in Lebanon in 2008 and the Imports (in Local Currency Unit) in West Bank and Gaza in 2010?
Your response must be concise. 3.03e+13. What is the difference between the Imports (in Local Currency Unit) in Niger in 2008 and the Imports (in Local Currency Unit) in West Bank and Gaza in 2010?
Your answer should be very brief. 8.44e+11. What is the difference between the Imports (in Local Currency Unit) of Chile in 2008 and the Imports (in Local Currency Unit) of Lebanon in 2011?
Your answer should be very brief. -1.67e+12. What is the difference between the Imports (in Local Currency Unit) of Chile in 2008 and the Imports (in Local Currency Unit) of Niger in 2011?
Ensure brevity in your answer.  3.57e+13. What is the difference between the Imports (in Local Currency Unit) in Chile in 2008 and the Imports (in Local Currency Unit) in West Bank and Gaza in 2011?
Your answer should be compact. 3.71e+13. What is the difference between the Imports (in Local Currency Unit) in Lebanon in 2008 and the Imports (in Local Currency Unit) in Niger in 2011?
Your answer should be very brief. 2.89e+13. What is the difference between the Imports (in Local Currency Unit) in Lebanon in 2008 and the Imports (in Local Currency Unit) in West Bank and Gaza in 2011?
Keep it short and to the point. 3.03e+13. What is the difference between the Imports (in Local Currency Unit) of Niger in 2008 and the Imports (in Local Currency Unit) of West Bank and Gaza in 2011?
Ensure brevity in your answer.  8.43e+11. What is the difference between the Imports (in Local Currency Unit) of Chile in 2008 and the Imports (in Local Currency Unit) of Lebanon in 2012?
Keep it short and to the point. -1.08e+13. What is the difference between the Imports (in Local Currency Unit) of Chile in 2008 and the Imports (in Local Currency Unit) of Niger in 2012?
Keep it short and to the point. 3.57e+13. What is the difference between the Imports (in Local Currency Unit) in Chile in 2008 and the Imports (in Local Currency Unit) in West Bank and Gaza in 2012?
Provide a short and direct response. 3.71e+13. What is the difference between the Imports (in Local Currency Unit) in Lebanon in 2008 and the Imports (in Local Currency Unit) in Niger in 2012?
Offer a very short reply. 2.90e+13. What is the difference between the Imports (in Local Currency Unit) of Lebanon in 2008 and the Imports (in Local Currency Unit) of West Bank and Gaza in 2012?
Your answer should be very brief. 3.03e+13. What is the difference between the Imports (in Local Currency Unit) of Niger in 2008 and the Imports (in Local Currency Unit) of West Bank and Gaza in 2012?
Provide a succinct answer. 8.39e+11. What is the difference between the Imports (in Local Currency Unit) of Chile in 2008 and the Imports (in Local Currency Unit) of Lebanon in 2013?
Give a very brief answer. -1.33e+13. What is the difference between the Imports (in Local Currency Unit) in Chile in 2008 and the Imports (in Local Currency Unit) in Niger in 2013?
Your response must be concise. 3.56e+13. What is the difference between the Imports (in Local Currency Unit) in Chile in 2008 and the Imports (in Local Currency Unit) in West Bank and Gaza in 2013?
Your response must be concise. 3.71e+13. What is the difference between the Imports (in Local Currency Unit) in Lebanon in 2008 and the Imports (in Local Currency Unit) in Niger in 2013?
Provide a succinct answer. 2.89e+13. What is the difference between the Imports (in Local Currency Unit) in Lebanon in 2008 and the Imports (in Local Currency Unit) in West Bank and Gaza in 2013?
Give a very brief answer. 3.03e+13. What is the difference between the Imports (in Local Currency Unit) in Niger in 2008 and the Imports (in Local Currency Unit) in West Bank and Gaza in 2013?
Make the answer very short. 8.39e+11. What is the difference between the Imports (in Local Currency Unit) in Chile in 2009 and the Imports (in Local Currency Unit) in Lebanon in 2010?
Offer a very short reply. -6.90e+12. What is the difference between the Imports (in Local Currency Unit) of Chile in 2009 and the Imports (in Local Currency Unit) of Niger in 2010?
Offer a terse response. 2.72e+13. What is the difference between the Imports (in Local Currency Unit) of Chile in 2009 and the Imports (in Local Currency Unit) of West Bank and Gaza in 2010?
Provide a short and direct response. 2.85e+13. What is the difference between the Imports (in Local Currency Unit) in Lebanon in 2009 and the Imports (in Local Currency Unit) in Niger in 2010?
Provide a short and direct response. 2.97e+13. What is the difference between the Imports (in Local Currency Unit) in Lebanon in 2009 and the Imports (in Local Currency Unit) in West Bank and Gaza in 2010?
Ensure brevity in your answer.  3.10e+13. What is the difference between the Imports (in Local Currency Unit) of Niger in 2009 and the Imports (in Local Currency Unit) of West Bank and Gaza in 2010?
Ensure brevity in your answer.  1.17e+12. What is the difference between the Imports (in Local Currency Unit) in Chile in 2009 and the Imports (in Local Currency Unit) in Lebanon in 2011?
Offer a very short reply. -1.02e+13. What is the difference between the Imports (in Local Currency Unit) of Chile in 2009 and the Imports (in Local Currency Unit) of Niger in 2011?
Offer a terse response. 2.71e+13. What is the difference between the Imports (in Local Currency Unit) of Chile in 2009 and the Imports (in Local Currency Unit) of West Bank and Gaza in 2011?
Make the answer very short. 2.85e+13. What is the difference between the Imports (in Local Currency Unit) of Lebanon in 2009 and the Imports (in Local Currency Unit) of Niger in 2011?
Your answer should be very brief. 2.96e+13. What is the difference between the Imports (in Local Currency Unit) in Lebanon in 2009 and the Imports (in Local Currency Unit) in West Bank and Gaza in 2011?
Your response must be concise. 3.10e+13. What is the difference between the Imports (in Local Currency Unit) of Niger in 2009 and the Imports (in Local Currency Unit) of West Bank and Gaza in 2011?
Make the answer very short. 1.17e+12. What is the difference between the Imports (in Local Currency Unit) of Chile in 2009 and the Imports (in Local Currency Unit) of Lebanon in 2012?
Offer a very short reply. -1.94e+13. What is the difference between the Imports (in Local Currency Unit) of Chile in 2009 and the Imports (in Local Currency Unit) of Niger in 2012?
Offer a terse response. 2.71e+13. What is the difference between the Imports (in Local Currency Unit) in Chile in 2009 and the Imports (in Local Currency Unit) in West Bank and Gaza in 2012?
Keep it short and to the point. 2.85e+13. What is the difference between the Imports (in Local Currency Unit) of Lebanon in 2009 and the Imports (in Local Currency Unit) of Niger in 2012?
Provide a short and direct response. 2.97e+13. What is the difference between the Imports (in Local Currency Unit) of Lebanon in 2009 and the Imports (in Local Currency Unit) of West Bank and Gaza in 2012?
Keep it short and to the point. 3.10e+13. What is the difference between the Imports (in Local Currency Unit) of Niger in 2009 and the Imports (in Local Currency Unit) of West Bank and Gaza in 2012?
Provide a short and direct response. 1.17e+12. What is the difference between the Imports (in Local Currency Unit) in Chile in 2009 and the Imports (in Local Currency Unit) in Lebanon in 2013?
Offer a very short reply. -2.19e+13. What is the difference between the Imports (in Local Currency Unit) in Chile in 2009 and the Imports (in Local Currency Unit) in Niger in 2013?
Your response must be concise. 2.71e+13. What is the difference between the Imports (in Local Currency Unit) in Chile in 2009 and the Imports (in Local Currency Unit) in West Bank and Gaza in 2013?
Ensure brevity in your answer.  2.85e+13. What is the difference between the Imports (in Local Currency Unit) in Lebanon in 2009 and the Imports (in Local Currency Unit) in Niger in 2013?
Make the answer very short. 2.96e+13. What is the difference between the Imports (in Local Currency Unit) in Lebanon in 2009 and the Imports (in Local Currency Unit) in West Bank and Gaza in 2013?
Ensure brevity in your answer.  3.10e+13. What is the difference between the Imports (in Local Currency Unit) of Niger in 2009 and the Imports (in Local Currency Unit) of West Bank and Gaza in 2013?
Your answer should be compact. 1.17e+12. What is the difference between the Imports (in Local Currency Unit) in Chile in 2010 and the Imports (in Local Currency Unit) in Lebanon in 2011?
Your response must be concise. -3.62e+12. What is the difference between the Imports (in Local Currency Unit) in Chile in 2010 and the Imports (in Local Currency Unit) in Niger in 2011?
Keep it short and to the point. 3.37e+13. What is the difference between the Imports (in Local Currency Unit) of Chile in 2010 and the Imports (in Local Currency Unit) of West Bank and Gaza in 2011?
Provide a succinct answer. 3.51e+13. What is the difference between the Imports (in Local Currency Unit) in Lebanon in 2010 and the Imports (in Local Currency Unit) in Niger in 2011?
Provide a succinct answer. 3.40e+13. What is the difference between the Imports (in Local Currency Unit) in Lebanon in 2010 and the Imports (in Local Currency Unit) in West Bank and Gaza in 2011?
Your answer should be very brief. 3.54e+13. What is the difference between the Imports (in Local Currency Unit) of Niger in 2010 and the Imports (in Local Currency Unit) of West Bank and Gaza in 2011?
Your response must be concise. 1.37e+12. What is the difference between the Imports (in Local Currency Unit) in Chile in 2010 and the Imports (in Local Currency Unit) in Lebanon in 2012?
Your answer should be compact. -1.28e+13. What is the difference between the Imports (in Local Currency Unit) in Chile in 2010 and the Imports (in Local Currency Unit) in Niger in 2012?
Your answer should be compact. 3.38e+13. What is the difference between the Imports (in Local Currency Unit) of Chile in 2010 and the Imports (in Local Currency Unit) of West Bank and Gaza in 2012?
Your response must be concise. 3.51e+13. What is the difference between the Imports (in Local Currency Unit) in Lebanon in 2010 and the Imports (in Local Currency Unit) in Niger in 2012?
Offer a very short reply. 3.40e+13. What is the difference between the Imports (in Local Currency Unit) of Lebanon in 2010 and the Imports (in Local Currency Unit) of West Bank and Gaza in 2012?
Provide a succinct answer. 3.54e+13. What is the difference between the Imports (in Local Currency Unit) in Niger in 2010 and the Imports (in Local Currency Unit) in West Bank and Gaza in 2012?
Provide a short and direct response. 1.37e+12. What is the difference between the Imports (in Local Currency Unit) of Chile in 2010 and the Imports (in Local Currency Unit) of Lebanon in 2013?
Give a very brief answer. -1.53e+13. What is the difference between the Imports (in Local Currency Unit) in Chile in 2010 and the Imports (in Local Currency Unit) in Niger in 2013?
Provide a succinct answer. 3.37e+13. What is the difference between the Imports (in Local Currency Unit) in Chile in 2010 and the Imports (in Local Currency Unit) in West Bank and Gaza in 2013?
Your response must be concise. 3.51e+13. What is the difference between the Imports (in Local Currency Unit) of Lebanon in 2010 and the Imports (in Local Currency Unit) of Niger in 2013?
Your answer should be compact. 3.40e+13. What is the difference between the Imports (in Local Currency Unit) of Lebanon in 2010 and the Imports (in Local Currency Unit) of West Bank and Gaza in 2013?
Provide a succinct answer. 3.54e+13. What is the difference between the Imports (in Local Currency Unit) of Niger in 2010 and the Imports (in Local Currency Unit) of West Bank and Gaza in 2013?
Your answer should be compact. 1.37e+12. What is the difference between the Imports (in Local Currency Unit) of Chile in 2011 and the Imports (in Local Currency Unit) of Lebanon in 2012?
Keep it short and to the point. -5.57e+12. What is the difference between the Imports (in Local Currency Unit) of Chile in 2011 and the Imports (in Local Currency Unit) of Niger in 2012?
Give a very brief answer. 4.09e+13. What is the difference between the Imports (in Local Currency Unit) of Chile in 2011 and the Imports (in Local Currency Unit) of West Bank and Gaza in 2012?
Make the answer very short. 4.23e+13. What is the difference between the Imports (in Local Currency Unit) in Lebanon in 2011 and the Imports (in Local Currency Unit) in Niger in 2012?
Provide a succinct answer. 3.74e+13. What is the difference between the Imports (in Local Currency Unit) in Lebanon in 2011 and the Imports (in Local Currency Unit) in West Bank and Gaza in 2012?
Your answer should be compact. 3.88e+13. What is the difference between the Imports (in Local Currency Unit) in Niger in 2011 and the Imports (in Local Currency Unit) in West Bank and Gaza in 2012?
Your answer should be compact. 1.42e+12. What is the difference between the Imports (in Local Currency Unit) of Chile in 2011 and the Imports (in Local Currency Unit) of Lebanon in 2013?
Your answer should be compact. -8.08e+12. What is the difference between the Imports (in Local Currency Unit) of Chile in 2011 and the Imports (in Local Currency Unit) of Niger in 2013?
Provide a succinct answer. 4.09e+13. What is the difference between the Imports (in Local Currency Unit) of Chile in 2011 and the Imports (in Local Currency Unit) of West Bank and Gaza in 2013?
Make the answer very short. 4.23e+13. What is the difference between the Imports (in Local Currency Unit) in Lebanon in 2011 and the Imports (in Local Currency Unit) in Niger in 2013?
Give a very brief answer. 3.73e+13. What is the difference between the Imports (in Local Currency Unit) in Lebanon in 2011 and the Imports (in Local Currency Unit) in West Bank and Gaza in 2013?
Make the answer very short. 3.88e+13. What is the difference between the Imports (in Local Currency Unit) in Niger in 2011 and the Imports (in Local Currency Unit) in West Bank and Gaza in 2013?
Ensure brevity in your answer.  1.42e+12. What is the difference between the Imports (in Local Currency Unit) in Chile in 2012 and the Imports (in Local Currency Unit) in Lebanon in 2013?
Offer a very short reply. -5.89e+12. What is the difference between the Imports (in Local Currency Unit) in Chile in 2012 and the Imports (in Local Currency Unit) in Niger in 2013?
Ensure brevity in your answer.  4.30e+13. What is the difference between the Imports (in Local Currency Unit) of Chile in 2012 and the Imports (in Local Currency Unit) of West Bank and Gaza in 2013?
Keep it short and to the point. 4.45e+13. What is the difference between the Imports (in Local Currency Unit) in Lebanon in 2012 and the Imports (in Local Currency Unit) in Niger in 2013?
Keep it short and to the point. 4.64e+13. What is the difference between the Imports (in Local Currency Unit) of Lebanon in 2012 and the Imports (in Local Currency Unit) of West Bank and Gaza in 2013?
Your answer should be compact. 4.79e+13. What is the difference between the Imports (in Local Currency Unit) in Niger in 2012 and the Imports (in Local Currency Unit) in West Bank and Gaza in 2013?
Your response must be concise. 1.37e+12. What is the average Imports (in Local Currency Unit) in Chile per year?
Your answer should be very brief. 3.58e+13. What is the average Imports (in Local Currency Unit) of Lebanon per year?
Make the answer very short. 3.45e+13. What is the average Imports (in Local Currency Unit) of Niger per year?
Your answer should be compact. 1.12e+12. What is the average Imports (in Local Currency Unit) in West Bank and Gaza per year?
Keep it short and to the point. 1.99e+1. In the year 2006, what is the difference between the Imports (in Local Currency Unit) of Chile and Imports (in Local Currency Unit) of Lebanon?
Ensure brevity in your answer.  5.16e+12. In the year 2006, what is the difference between the Imports (in Local Currency Unit) of Chile and Imports (in Local Currency Unit) of Niger?
Your response must be concise. 2.36e+13. In the year 2006, what is the difference between the Imports (in Local Currency Unit) of Chile and Imports (in Local Currency Unit) of West Bank and Gaza?
Ensure brevity in your answer.  2.42e+13. In the year 2006, what is the difference between the Imports (in Local Currency Unit) of Lebanon and Imports (in Local Currency Unit) of Niger?
Your answer should be compact. 1.85e+13. In the year 2006, what is the difference between the Imports (in Local Currency Unit) in Lebanon and Imports (in Local Currency Unit) in West Bank and Gaza?
Make the answer very short. 1.90e+13. In the year 2006, what is the difference between the Imports (in Local Currency Unit) in Niger and Imports (in Local Currency Unit) in West Bank and Gaza?
Your answer should be very brief. 5.46e+11. In the year 2007, what is the difference between the Imports (in Local Currency Unit) of Chile and Imports (in Local Currency Unit) of Lebanon?
Give a very brief answer. 5.54e+12. In the year 2007, what is the difference between the Imports (in Local Currency Unit) in Chile and Imports (in Local Currency Unit) in Niger?
Provide a short and direct response. 2.83e+13. In the year 2007, what is the difference between the Imports (in Local Currency Unit) in Chile and Imports (in Local Currency Unit) in West Bank and Gaza?
Your answer should be compact. 2.89e+13. In the year 2007, what is the difference between the Imports (in Local Currency Unit) in Lebanon and Imports (in Local Currency Unit) in Niger?
Provide a short and direct response. 2.27e+13. In the year 2007, what is the difference between the Imports (in Local Currency Unit) in Lebanon and Imports (in Local Currency Unit) in West Bank and Gaza?
Your response must be concise. 2.33e+13. In the year 2007, what is the difference between the Imports (in Local Currency Unit) in Niger and Imports (in Local Currency Unit) in West Bank and Gaza?
Offer a terse response. 5.98e+11. In the year 2008, what is the difference between the Imports (in Local Currency Unit) of Chile and Imports (in Local Currency Unit) of Lebanon?
Your answer should be very brief. 6.74e+12. In the year 2008, what is the difference between the Imports (in Local Currency Unit) in Chile and Imports (in Local Currency Unit) in Niger?
Your answer should be compact. 3.62e+13. In the year 2008, what is the difference between the Imports (in Local Currency Unit) of Chile and Imports (in Local Currency Unit) of West Bank and Gaza?
Provide a short and direct response. 3.71e+13. In the year 2008, what is the difference between the Imports (in Local Currency Unit) of Lebanon and Imports (in Local Currency Unit) of Niger?
Ensure brevity in your answer.  2.95e+13. In the year 2008, what is the difference between the Imports (in Local Currency Unit) in Lebanon and Imports (in Local Currency Unit) in West Bank and Gaza?
Provide a succinct answer. 3.03e+13. In the year 2008, what is the difference between the Imports (in Local Currency Unit) in Niger and Imports (in Local Currency Unit) in West Bank and Gaza?
Keep it short and to the point. 8.47e+11. In the year 2009, what is the difference between the Imports (in Local Currency Unit) in Chile and Imports (in Local Currency Unit) in Lebanon?
Make the answer very short. -2.52e+12. In the year 2009, what is the difference between the Imports (in Local Currency Unit) in Chile and Imports (in Local Currency Unit) in Niger?
Provide a short and direct response. 2.74e+13. In the year 2009, what is the difference between the Imports (in Local Currency Unit) in Chile and Imports (in Local Currency Unit) in West Bank and Gaza?
Your answer should be very brief. 2.85e+13. In the year 2009, what is the difference between the Imports (in Local Currency Unit) of Lebanon and Imports (in Local Currency Unit) of Niger?
Provide a short and direct response. 2.99e+13. In the year 2009, what is the difference between the Imports (in Local Currency Unit) in Lebanon and Imports (in Local Currency Unit) in West Bank and Gaza?
Provide a succinct answer. 3.10e+13. In the year 2009, what is the difference between the Imports (in Local Currency Unit) of Niger and Imports (in Local Currency Unit) of West Bank and Gaza?
Your answer should be compact. 1.17e+12. In the year 2010, what is the difference between the Imports (in Local Currency Unit) in Chile and Imports (in Local Currency Unit) in Lebanon?
Give a very brief answer. -2.91e+11. In the year 2010, what is the difference between the Imports (in Local Currency Unit) of Chile and Imports (in Local Currency Unit) of Niger?
Keep it short and to the point. 3.38e+13. In the year 2010, what is the difference between the Imports (in Local Currency Unit) in Chile and Imports (in Local Currency Unit) in West Bank and Gaza?
Give a very brief answer. 3.51e+13. In the year 2010, what is the difference between the Imports (in Local Currency Unit) of Lebanon and Imports (in Local Currency Unit) of Niger?
Keep it short and to the point. 3.41e+13. In the year 2010, what is the difference between the Imports (in Local Currency Unit) in Lebanon and Imports (in Local Currency Unit) in West Bank and Gaza?
Provide a short and direct response. 3.54e+13. In the year 2010, what is the difference between the Imports (in Local Currency Unit) in Niger and Imports (in Local Currency Unit) in West Bank and Gaza?
Offer a very short reply. 1.37e+12. In the year 2011, what is the difference between the Imports (in Local Currency Unit) of Chile and Imports (in Local Currency Unit) of Lebanon?
Offer a very short reply. 3.56e+12. In the year 2011, what is the difference between the Imports (in Local Currency Unit) of Chile and Imports (in Local Currency Unit) of Niger?
Give a very brief answer. 4.09e+13. In the year 2011, what is the difference between the Imports (in Local Currency Unit) in Chile and Imports (in Local Currency Unit) in West Bank and Gaza?
Provide a short and direct response. 4.23e+13. In the year 2011, what is the difference between the Imports (in Local Currency Unit) in Lebanon and Imports (in Local Currency Unit) in Niger?
Make the answer very short. 3.73e+13. In the year 2011, what is the difference between the Imports (in Local Currency Unit) of Lebanon and Imports (in Local Currency Unit) of West Bank and Gaza?
Your answer should be compact. 3.88e+13. In the year 2011, what is the difference between the Imports (in Local Currency Unit) of Niger and Imports (in Local Currency Unit) of West Bank and Gaza?
Provide a succinct answer. 1.42e+12. In the year 2012, what is the difference between the Imports (in Local Currency Unit) in Chile and Imports (in Local Currency Unit) in Lebanon?
Offer a very short reply. -3.38e+12. In the year 2012, what is the difference between the Imports (in Local Currency Unit) of Chile and Imports (in Local Currency Unit) of Niger?
Your response must be concise. 4.31e+13. In the year 2012, what is the difference between the Imports (in Local Currency Unit) of Chile and Imports (in Local Currency Unit) of West Bank and Gaza?
Ensure brevity in your answer.  4.45e+13. In the year 2012, what is the difference between the Imports (in Local Currency Unit) in Lebanon and Imports (in Local Currency Unit) in Niger?
Offer a very short reply. 4.65e+13. In the year 2012, what is the difference between the Imports (in Local Currency Unit) of Lebanon and Imports (in Local Currency Unit) of West Bank and Gaza?
Provide a short and direct response. 4.79e+13. In the year 2012, what is the difference between the Imports (in Local Currency Unit) in Niger and Imports (in Local Currency Unit) in West Bank and Gaza?
Offer a terse response. 1.37e+12. In the year 2013, what is the difference between the Imports (in Local Currency Unit) of Chile and Imports (in Local Currency Unit) of Lebanon?
Your answer should be compact. -5.11e+12. In the year 2013, what is the difference between the Imports (in Local Currency Unit) in Chile and Imports (in Local Currency Unit) in Niger?
Your answer should be compact. 4.38e+13. In the year 2013, what is the difference between the Imports (in Local Currency Unit) of Chile and Imports (in Local Currency Unit) of West Bank and Gaza?
Make the answer very short. 4.53e+13. In the year 2013, what is the difference between the Imports (in Local Currency Unit) in Lebanon and Imports (in Local Currency Unit) in Niger?
Offer a very short reply. 4.89e+13. In the year 2013, what is the difference between the Imports (in Local Currency Unit) in Lebanon and Imports (in Local Currency Unit) in West Bank and Gaza?
Your answer should be compact. 5.04e+13. In the year 2013, what is the difference between the Imports (in Local Currency Unit) in Niger and Imports (in Local Currency Unit) in West Bank and Gaza?
Your answer should be compact. 1.46e+12. What is the ratio of the Imports (in Local Currency Unit) in Chile in 2006 to that in 2007?
Provide a short and direct response. 0.84. What is the ratio of the Imports (in Local Currency Unit) of Lebanon in 2006 to that in 2007?
Your answer should be compact. 0.82. What is the ratio of the Imports (in Local Currency Unit) of Niger in 2006 to that in 2007?
Give a very brief answer. 0.91. What is the ratio of the Imports (in Local Currency Unit) of West Bank and Gaza in 2006 to that in 2007?
Offer a very short reply. 0.93. What is the ratio of the Imports (in Local Currency Unit) in Chile in 2006 to that in 2008?
Your answer should be compact. 0.65. What is the ratio of the Imports (in Local Currency Unit) of Lebanon in 2006 to that in 2008?
Ensure brevity in your answer.  0.63. What is the ratio of the Imports (in Local Currency Unit) in Niger in 2006 to that in 2008?
Your answer should be very brief. 0.65. What is the ratio of the Imports (in Local Currency Unit) in West Bank and Gaza in 2006 to that in 2008?
Offer a very short reply. 1. What is the ratio of the Imports (in Local Currency Unit) in Chile in 2006 to that in 2009?
Your response must be concise. 0.85. What is the ratio of the Imports (in Local Currency Unit) of Lebanon in 2006 to that in 2009?
Your answer should be compact. 0.61. What is the ratio of the Imports (in Local Currency Unit) in Niger in 2006 to that in 2009?
Offer a terse response. 0.47. What is the ratio of the Imports (in Local Currency Unit) of West Bank and Gaza in 2006 to that in 2009?
Provide a short and direct response. 0.84. What is the ratio of the Imports (in Local Currency Unit) in Chile in 2006 to that in 2010?
Your answer should be very brief. 0.69. What is the ratio of the Imports (in Local Currency Unit) of Lebanon in 2006 to that in 2010?
Make the answer very short. 0.54. What is the ratio of the Imports (in Local Currency Unit) in Niger in 2006 to that in 2010?
Your response must be concise. 0.4. What is the ratio of the Imports (in Local Currency Unit) in West Bank and Gaza in 2006 to that in 2010?
Your answer should be compact. 0.84. What is the ratio of the Imports (in Local Currency Unit) of Chile in 2006 to that in 2011?
Your answer should be compact. 0.57. What is the ratio of the Imports (in Local Currency Unit) of Lebanon in 2006 to that in 2011?
Your answer should be very brief. 0.49. What is the ratio of the Imports (in Local Currency Unit) of Niger in 2006 to that in 2011?
Make the answer very short. 0.39. What is the ratio of the Imports (in Local Currency Unit) of West Bank and Gaza in 2006 to that in 2011?
Provide a succinct answer. 0.8. What is the ratio of the Imports (in Local Currency Unit) in Chile in 2006 to that in 2012?
Provide a short and direct response. 0.54. What is the ratio of the Imports (in Local Currency Unit) in Lebanon in 2006 to that in 2012?
Offer a terse response. 0.4. What is the ratio of the Imports (in Local Currency Unit) in Niger in 2006 to that in 2012?
Give a very brief answer. 0.4. What is the ratio of the Imports (in Local Currency Unit) of West Bank and Gaza in 2006 to that in 2012?
Provide a succinct answer. 0.68. What is the ratio of the Imports (in Local Currency Unit) of Chile in 2006 to that in 2013?
Your answer should be very brief. 0.53. What is the ratio of the Imports (in Local Currency Unit) of Lebanon in 2006 to that in 2013?
Your answer should be compact. 0.38. What is the ratio of the Imports (in Local Currency Unit) in Niger in 2006 to that in 2013?
Your answer should be compact. 0.38. What is the ratio of the Imports (in Local Currency Unit) of West Bank and Gaza in 2006 to that in 2013?
Give a very brief answer. 0.67. What is the ratio of the Imports (in Local Currency Unit) of Chile in 2007 to that in 2008?
Provide a short and direct response. 0.78. What is the ratio of the Imports (in Local Currency Unit) in Lebanon in 2007 to that in 2008?
Provide a succinct answer. 0.77. What is the ratio of the Imports (in Local Currency Unit) in Niger in 2007 to that in 2008?
Provide a short and direct response. 0.71. What is the ratio of the Imports (in Local Currency Unit) of West Bank and Gaza in 2007 to that in 2008?
Provide a succinct answer. 1.07. What is the ratio of the Imports (in Local Currency Unit) in Chile in 2007 to that in 2009?
Offer a terse response. 1.01. What is the ratio of the Imports (in Local Currency Unit) of Lebanon in 2007 to that in 2009?
Your answer should be very brief. 0.75. What is the ratio of the Imports (in Local Currency Unit) of Niger in 2007 to that in 2009?
Offer a terse response. 0.52. What is the ratio of the Imports (in Local Currency Unit) of West Bank and Gaza in 2007 to that in 2009?
Your answer should be very brief. 0.9. What is the ratio of the Imports (in Local Currency Unit) in Chile in 2007 to that in 2010?
Give a very brief answer. 0.82. What is the ratio of the Imports (in Local Currency Unit) in Lebanon in 2007 to that in 2010?
Make the answer very short. 0.66. What is the ratio of the Imports (in Local Currency Unit) of Niger in 2007 to that in 2010?
Make the answer very short. 0.44. What is the ratio of the Imports (in Local Currency Unit) in West Bank and Gaza in 2007 to that in 2010?
Offer a terse response. 0.9. What is the ratio of the Imports (in Local Currency Unit) in Chile in 2007 to that in 2011?
Your response must be concise. 0.68. What is the ratio of the Imports (in Local Currency Unit) of Lebanon in 2007 to that in 2011?
Make the answer very short. 0.6. What is the ratio of the Imports (in Local Currency Unit) of Niger in 2007 to that in 2011?
Offer a very short reply. 0.43. What is the ratio of the Imports (in Local Currency Unit) in West Bank and Gaza in 2007 to that in 2011?
Offer a very short reply. 0.86. What is the ratio of the Imports (in Local Currency Unit) in Chile in 2007 to that in 2012?
Ensure brevity in your answer.  0.65. What is the ratio of the Imports (in Local Currency Unit) in Lebanon in 2007 to that in 2012?
Give a very brief answer. 0.49. What is the ratio of the Imports (in Local Currency Unit) of Niger in 2007 to that in 2012?
Your answer should be compact. 0.44. What is the ratio of the Imports (in Local Currency Unit) in West Bank and Gaza in 2007 to that in 2012?
Provide a short and direct response. 0.73. What is the ratio of the Imports (in Local Currency Unit) of Chile in 2007 to that in 2013?
Your response must be concise. 0.64. What is the ratio of the Imports (in Local Currency Unit) of Lebanon in 2007 to that in 2013?
Your response must be concise. 0.46. What is the ratio of the Imports (in Local Currency Unit) of Niger in 2007 to that in 2013?
Your answer should be compact. 0.42. What is the ratio of the Imports (in Local Currency Unit) of West Bank and Gaza in 2007 to that in 2013?
Provide a succinct answer. 0.72. What is the ratio of the Imports (in Local Currency Unit) in Chile in 2008 to that in 2009?
Ensure brevity in your answer.  1.3. What is the ratio of the Imports (in Local Currency Unit) in Lebanon in 2008 to that in 2009?
Your response must be concise. 0.98. What is the ratio of the Imports (in Local Currency Unit) of Niger in 2008 to that in 2009?
Provide a succinct answer. 0.72. What is the ratio of the Imports (in Local Currency Unit) of West Bank and Gaza in 2008 to that in 2009?
Offer a very short reply. 0.84. What is the ratio of the Imports (in Local Currency Unit) of Chile in 2008 to that in 2010?
Your response must be concise. 1.06. What is the ratio of the Imports (in Local Currency Unit) in Lebanon in 2008 to that in 2010?
Ensure brevity in your answer.  0.86. What is the ratio of the Imports (in Local Currency Unit) of Niger in 2008 to that in 2010?
Ensure brevity in your answer.  0.62. What is the ratio of the Imports (in Local Currency Unit) in West Bank and Gaza in 2008 to that in 2010?
Your answer should be very brief. 0.84. What is the ratio of the Imports (in Local Currency Unit) of Chile in 2008 to that in 2011?
Make the answer very short. 0.88. What is the ratio of the Imports (in Local Currency Unit) in Lebanon in 2008 to that in 2011?
Keep it short and to the point. 0.78. What is the ratio of the Imports (in Local Currency Unit) of Niger in 2008 to that in 2011?
Make the answer very short. 0.6. What is the ratio of the Imports (in Local Currency Unit) in West Bank and Gaza in 2008 to that in 2011?
Make the answer very short. 0.8. What is the ratio of the Imports (in Local Currency Unit) in Chile in 2008 to that in 2012?
Provide a short and direct response. 0.83. What is the ratio of the Imports (in Local Currency Unit) of Lebanon in 2008 to that in 2012?
Offer a very short reply. 0.63. What is the ratio of the Imports (in Local Currency Unit) in Niger in 2008 to that in 2012?
Your answer should be compact. 0.62. What is the ratio of the Imports (in Local Currency Unit) of West Bank and Gaza in 2008 to that in 2012?
Your response must be concise. 0.68. What is the ratio of the Imports (in Local Currency Unit) of Chile in 2008 to that in 2013?
Your answer should be compact. 0.82. What is the ratio of the Imports (in Local Currency Unit) in Lebanon in 2008 to that in 2013?
Your response must be concise. 0.6. What is the ratio of the Imports (in Local Currency Unit) in Niger in 2008 to that in 2013?
Provide a succinct answer. 0.58. What is the ratio of the Imports (in Local Currency Unit) of West Bank and Gaza in 2008 to that in 2013?
Keep it short and to the point. 0.67. What is the ratio of the Imports (in Local Currency Unit) in Chile in 2009 to that in 2010?
Offer a terse response. 0.81. What is the ratio of the Imports (in Local Currency Unit) of Lebanon in 2009 to that in 2010?
Ensure brevity in your answer.  0.88. What is the ratio of the Imports (in Local Currency Unit) in Niger in 2009 to that in 2010?
Ensure brevity in your answer.  0.86. What is the ratio of the Imports (in Local Currency Unit) in West Bank and Gaza in 2009 to that in 2010?
Make the answer very short. 0.99. What is the ratio of the Imports (in Local Currency Unit) of Chile in 2009 to that in 2011?
Offer a terse response. 0.67. What is the ratio of the Imports (in Local Currency Unit) in Lebanon in 2009 to that in 2011?
Your answer should be compact. 0.8. What is the ratio of the Imports (in Local Currency Unit) of Niger in 2009 to that in 2011?
Make the answer very short. 0.83. What is the ratio of the Imports (in Local Currency Unit) of West Bank and Gaza in 2009 to that in 2011?
Make the answer very short. 0.95. What is the ratio of the Imports (in Local Currency Unit) in Chile in 2009 to that in 2012?
Your answer should be compact. 0.64. What is the ratio of the Imports (in Local Currency Unit) of Lebanon in 2009 to that in 2012?
Your answer should be compact. 0.65. What is the ratio of the Imports (in Local Currency Unit) of Niger in 2009 to that in 2012?
Ensure brevity in your answer.  0.86. What is the ratio of the Imports (in Local Currency Unit) of West Bank and Gaza in 2009 to that in 2012?
Your answer should be compact. 0.8. What is the ratio of the Imports (in Local Currency Unit) in Chile in 2009 to that in 2013?
Offer a very short reply. 0.63. What is the ratio of the Imports (in Local Currency Unit) in Lebanon in 2009 to that in 2013?
Keep it short and to the point. 0.62. What is the ratio of the Imports (in Local Currency Unit) in Niger in 2009 to that in 2013?
Provide a succinct answer. 0.81. What is the ratio of the Imports (in Local Currency Unit) in West Bank and Gaza in 2009 to that in 2013?
Provide a succinct answer. 0.79. What is the ratio of the Imports (in Local Currency Unit) of Chile in 2010 to that in 2011?
Make the answer very short. 0.83. What is the ratio of the Imports (in Local Currency Unit) of Lebanon in 2010 to that in 2011?
Your answer should be very brief. 0.91. What is the ratio of the Imports (in Local Currency Unit) in Niger in 2010 to that in 2011?
Your response must be concise. 0.96. What is the ratio of the Imports (in Local Currency Unit) of West Bank and Gaza in 2010 to that in 2011?
Provide a succinct answer. 0.96. What is the ratio of the Imports (in Local Currency Unit) of Chile in 2010 to that in 2012?
Your response must be concise. 0.79. What is the ratio of the Imports (in Local Currency Unit) of Lebanon in 2010 to that in 2012?
Your answer should be compact. 0.74. What is the ratio of the Imports (in Local Currency Unit) of Niger in 2010 to that in 2012?
Provide a short and direct response. 1. What is the ratio of the Imports (in Local Currency Unit) of West Bank and Gaza in 2010 to that in 2012?
Provide a short and direct response. 0.81. What is the ratio of the Imports (in Local Currency Unit) in Chile in 2010 to that in 2013?
Your response must be concise. 0.78. What is the ratio of the Imports (in Local Currency Unit) in Lebanon in 2010 to that in 2013?
Ensure brevity in your answer.  0.7. What is the ratio of the Imports (in Local Currency Unit) of Niger in 2010 to that in 2013?
Keep it short and to the point. 0.94. What is the ratio of the Imports (in Local Currency Unit) in West Bank and Gaza in 2010 to that in 2013?
Provide a succinct answer. 0.8. What is the ratio of the Imports (in Local Currency Unit) in Chile in 2011 to that in 2012?
Your answer should be very brief. 0.95. What is the ratio of the Imports (in Local Currency Unit) in Lebanon in 2011 to that in 2012?
Provide a succinct answer. 0.81. What is the ratio of the Imports (in Local Currency Unit) in Niger in 2011 to that in 2012?
Provide a succinct answer. 1.04. What is the ratio of the Imports (in Local Currency Unit) of West Bank and Gaza in 2011 to that in 2012?
Provide a short and direct response. 0.84. What is the ratio of the Imports (in Local Currency Unit) in Chile in 2011 to that in 2013?
Your answer should be compact. 0.93. What is the ratio of the Imports (in Local Currency Unit) in Lebanon in 2011 to that in 2013?
Ensure brevity in your answer.  0.77. What is the ratio of the Imports (in Local Currency Unit) in Niger in 2011 to that in 2013?
Give a very brief answer. 0.98. What is the ratio of the Imports (in Local Currency Unit) of West Bank and Gaza in 2011 to that in 2013?
Ensure brevity in your answer.  0.83. What is the ratio of the Imports (in Local Currency Unit) in Chile in 2012 to that in 2013?
Your answer should be very brief. 0.98. What is the ratio of the Imports (in Local Currency Unit) in Lebanon in 2012 to that in 2013?
Keep it short and to the point. 0.95. What is the ratio of the Imports (in Local Currency Unit) of Niger in 2012 to that in 2013?
Your response must be concise. 0.94. What is the ratio of the Imports (in Local Currency Unit) of West Bank and Gaza in 2012 to that in 2013?
Keep it short and to the point. 0.99. What is the difference between the highest and the second highest Imports (in Local Currency Unit) of Chile?
Give a very brief answer. 7.85e+11. What is the difference between the highest and the second highest Imports (in Local Currency Unit) in Lebanon?
Keep it short and to the point. 2.51e+12. What is the difference between the highest and the second highest Imports (in Local Currency Unit) in Niger?
Provide a succinct answer. 3.53e+1. What is the difference between the highest and the second highest Imports (in Local Currency Unit) of West Bank and Gaza?
Ensure brevity in your answer.  3.08e+08. What is the difference between the highest and the lowest Imports (in Local Currency Unit) in Chile?
Offer a terse response. 2.11e+13. What is the difference between the highest and the lowest Imports (in Local Currency Unit) in Lebanon?
Offer a terse response. 3.14e+13. What is the difference between the highest and the lowest Imports (in Local Currency Unit) of Niger?
Give a very brief answer. 9.18e+11. What is the difference between the highest and the lowest Imports (in Local Currency Unit) of West Bank and Gaza?
Provide a short and direct response. 8.13e+09. 